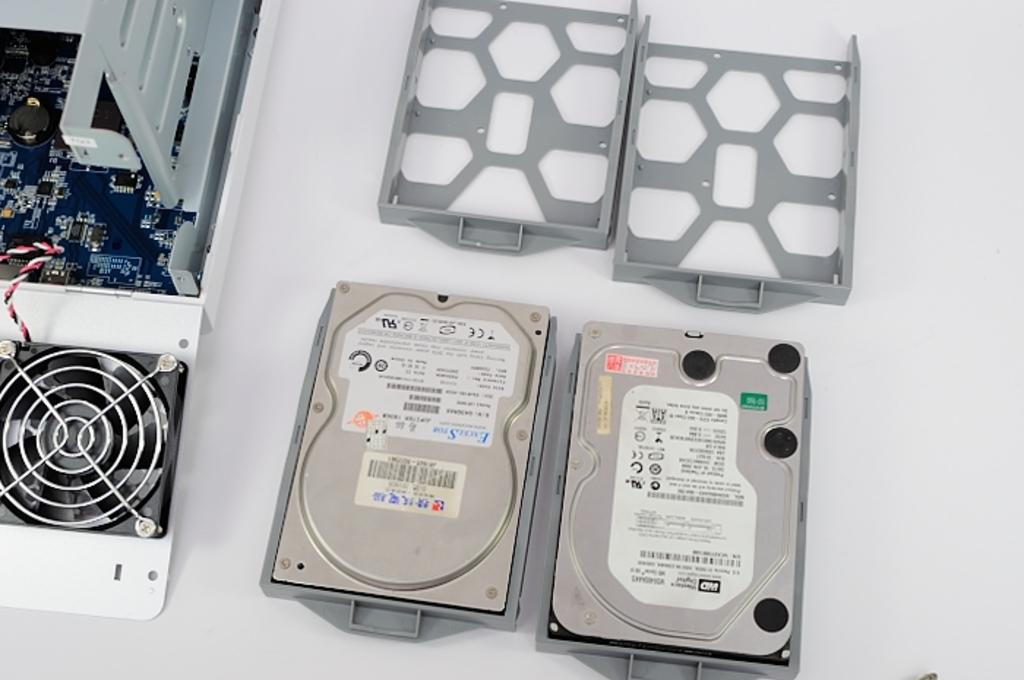What type of objects are present in the image? There are metal objects in the image. What else can be seen in the image besides the metal objects? There is a circuit in the image. Where are the metal objects and circuit located? The metal objects and circuit are on a table. What type of coat is draped over the circuit in the image? There is no coat present in the image; it only features metal objects and a circuit on a table. 